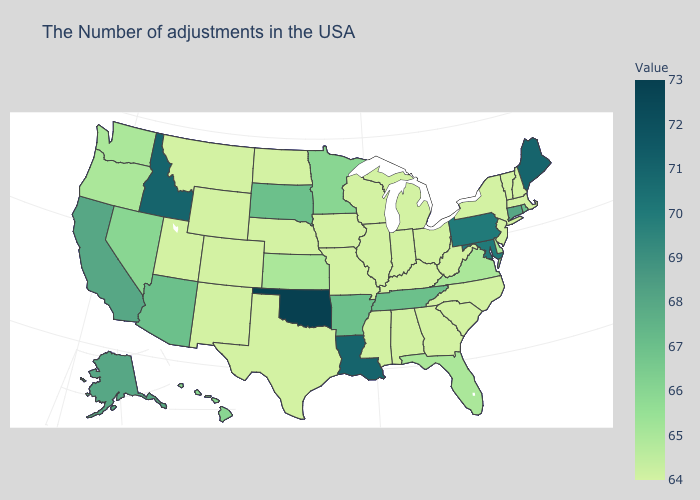Does Oklahoma have the highest value in the USA?
Quick response, please. Yes. Does Michigan have a lower value than Oklahoma?
Give a very brief answer. Yes. Among the states that border Louisiana , does Mississippi have the lowest value?
Give a very brief answer. Yes. Does the map have missing data?
Write a very short answer. No. Among the states that border Wyoming , does South Dakota have the lowest value?
Be succinct. No. Among the states that border Connecticut , which have the highest value?
Quick response, please. Rhode Island. 